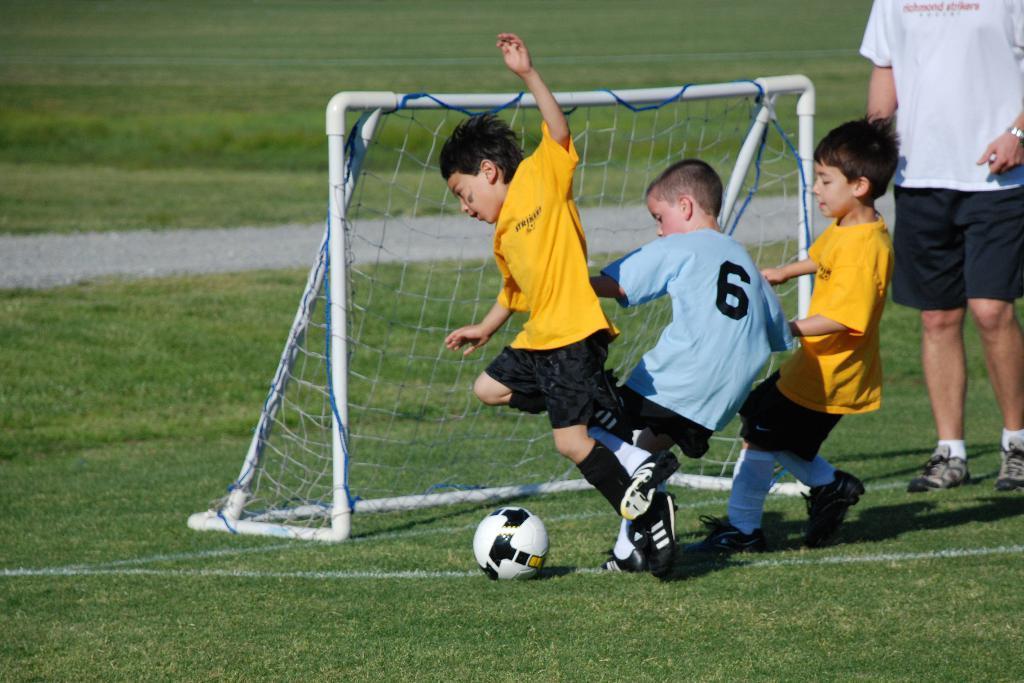Please provide a concise description of this image. In front of the picture, we see the boys are playing the football. In front of them, we see the net. At the bottom, we see the grass. On the right side, we see the man in the white T-shirt is standing. In the background, we see the grass. This picture might be clicked in the football field. 